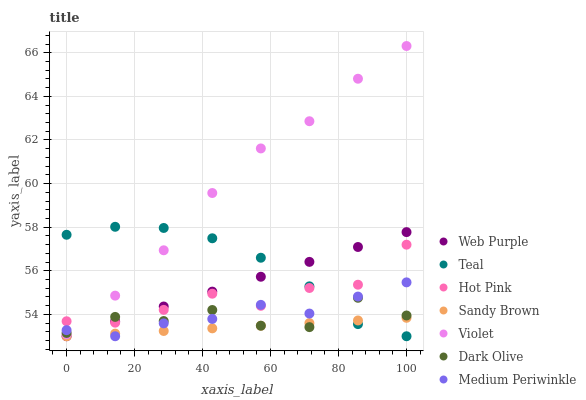Does Sandy Brown have the minimum area under the curve?
Answer yes or no. Yes. Does Violet have the maximum area under the curve?
Answer yes or no. Yes. Does Dark Olive have the minimum area under the curve?
Answer yes or no. No. Does Dark Olive have the maximum area under the curve?
Answer yes or no. No. Is Web Purple the smoothest?
Answer yes or no. Yes. Is Dark Olive the roughest?
Answer yes or no. Yes. Is Medium Periwinkle the smoothest?
Answer yes or no. No. Is Medium Periwinkle the roughest?
Answer yes or no. No. Does Medium Periwinkle have the lowest value?
Answer yes or no. Yes. Does Dark Olive have the lowest value?
Answer yes or no. No. Does Violet have the highest value?
Answer yes or no. Yes. Does Dark Olive have the highest value?
Answer yes or no. No. Is Sandy Brown less than Violet?
Answer yes or no. Yes. Is Violet greater than Sandy Brown?
Answer yes or no. Yes. Does Dark Olive intersect Hot Pink?
Answer yes or no. Yes. Is Dark Olive less than Hot Pink?
Answer yes or no. No. Is Dark Olive greater than Hot Pink?
Answer yes or no. No. Does Sandy Brown intersect Violet?
Answer yes or no. No. 